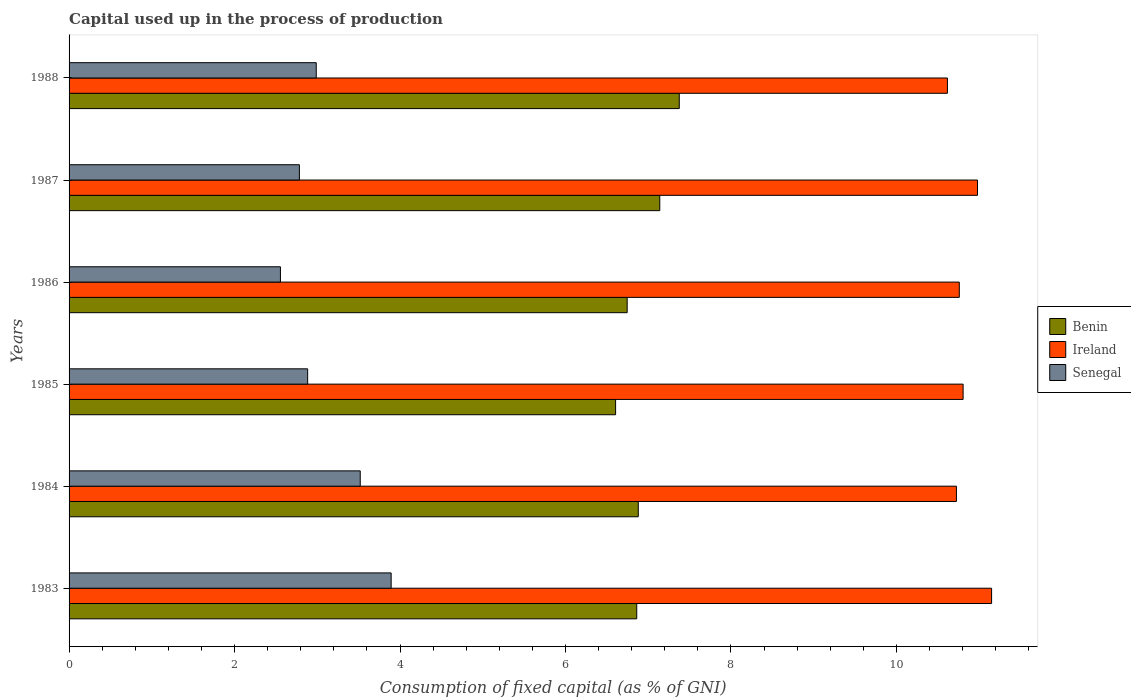Are the number of bars per tick equal to the number of legend labels?
Offer a terse response. Yes. Are the number of bars on each tick of the Y-axis equal?
Provide a succinct answer. Yes. What is the label of the 3rd group of bars from the top?
Ensure brevity in your answer.  1986. What is the capital used up in the process of production in Senegal in 1988?
Provide a succinct answer. 2.99. Across all years, what is the maximum capital used up in the process of production in Senegal?
Keep it short and to the point. 3.89. Across all years, what is the minimum capital used up in the process of production in Ireland?
Your answer should be compact. 10.62. In which year was the capital used up in the process of production in Ireland maximum?
Give a very brief answer. 1983. In which year was the capital used up in the process of production in Ireland minimum?
Your response must be concise. 1988. What is the total capital used up in the process of production in Benin in the graph?
Your answer should be compact. 41.61. What is the difference between the capital used up in the process of production in Senegal in 1985 and that in 1988?
Your answer should be compact. -0.1. What is the difference between the capital used up in the process of production in Ireland in 1988 and the capital used up in the process of production in Benin in 1985?
Your response must be concise. 4.01. What is the average capital used up in the process of production in Ireland per year?
Keep it short and to the point. 10.84. In the year 1987, what is the difference between the capital used up in the process of production in Benin and capital used up in the process of production in Senegal?
Offer a terse response. 4.36. What is the ratio of the capital used up in the process of production in Senegal in 1985 to that in 1986?
Give a very brief answer. 1.13. Is the capital used up in the process of production in Benin in 1985 less than that in 1986?
Keep it short and to the point. Yes. Is the difference between the capital used up in the process of production in Benin in 1984 and 1987 greater than the difference between the capital used up in the process of production in Senegal in 1984 and 1987?
Your response must be concise. No. What is the difference between the highest and the second highest capital used up in the process of production in Ireland?
Keep it short and to the point. 0.17. What is the difference between the highest and the lowest capital used up in the process of production in Benin?
Your answer should be compact. 0.77. In how many years, is the capital used up in the process of production in Ireland greater than the average capital used up in the process of production in Ireland taken over all years?
Provide a short and direct response. 2. What does the 1st bar from the top in 1985 represents?
Keep it short and to the point. Senegal. What does the 3rd bar from the bottom in 1986 represents?
Make the answer very short. Senegal. Is it the case that in every year, the sum of the capital used up in the process of production in Benin and capital used up in the process of production in Senegal is greater than the capital used up in the process of production in Ireland?
Keep it short and to the point. No. How many years are there in the graph?
Your response must be concise. 6. What is the difference between two consecutive major ticks on the X-axis?
Your answer should be very brief. 2. Are the values on the major ticks of X-axis written in scientific E-notation?
Keep it short and to the point. No. What is the title of the graph?
Offer a very short reply. Capital used up in the process of production. What is the label or title of the X-axis?
Provide a succinct answer. Consumption of fixed capital (as % of GNI). What is the Consumption of fixed capital (as % of GNI) in Benin in 1983?
Your answer should be very brief. 6.86. What is the Consumption of fixed capital (as % of GNI) in Ireland in 1983?
Your response must be concise. 11.15. What is the Consumption of fixed capital (as % of GNI) of Senegal in 1983?
Provide a short and direct response. 3.89. What is the Consumption of fixed capital (as % of GNI) of Benin in 1984?
Make the answer very short. 6.88. What is the Consumption of fixed capital (as % of GNI) of Ireland in 1984?
Give a very brief answer. 10.72. What is the Consumption of fixed capital (as % of GNI) of Senegal in 1984?
Offer a terse response. 3.52. What is the Consumption of fixed capital (as % of GNI) in Benin in 1985?
Keep it short and to the point. 6.61. What is the Consumption of fixed capital (as % of GNI) of Ireland in 1985?
Ensure brevity in your answer.  10.81. What is the Consumption of fixed capital (as % of GNI) in Senegal in 1985?
Make the answer very short. 2.88. What is the Consumption of fixed capital (as % of GNI) in Benin in 1986?
Your answer should be very brief. 6.75. What is the Consumption of fixed capital (as % of GNI) of Ireland in 1986?
Keep it short and to the point. 10.76. What is the Consumption of fixed capital (as % of GNI) in Senegal in 1986?
Keep it short and to the point. 2.55. What is the Consumption of fixed capital (as % of GNI) of Benin in 1987?
Make the answer very short. 7.14. What is the Consumption of fixed capital (as % of GNI) in Ireland in 1987?
Offer a very short reply. 10.98. What is the Consumption of fixed capital (as % of GNI) of Senegal in 1987?
Your response must be concise. 2.78. What is the Consumption of fixed capital (as % of GNI) in Benin in 1988?
Make the answer very short. 7.37. What is the Consumption of fixed capital (as % of GNI) in Ireland in 1988?
Provide a succinct answer. 10.62. What is the Consumption of fixed capital (as % of GNI) of Senegal in 1988?
Your response must be concise. 2.99. Across all years, what is the maximum Consumption of fixed capital (as % of GNI) in Benin?
Offer a very short reply. 7.37. Across all years, what is the maximum Consumption of fixed capital (as % of GNI) of Ireland?
Your answer should be compact. 11.15. Across all years, what is the maximum Consumption of fixed capital (as % of GNI) in Senegal?
Your response must be concise. 3.89. Across all years, what is the minimum Consumption of fixed capital (as % of GNI) of Benin?
Offer a very short reply. 6.61. Across all years, what is the minimum Consumption of fixed capital (as % of GNI) in Ireland?
Provide a succinct answer. 10.62. Across all years, what is the minimum Consumption of fixed capital (as % of GNI) of Senegal?
Offer a terse response. 2.55. What is the total Consumption of fixed capital (as % of GNI) of Benin in the graph?
Offer a terse response. 41.61. What is the total Consumption of fixed capital (as % of GNI) in Ireland in the graph?
Offer a very short reply. 65.03. What is the total Consumption of fixed capital (as % of GNI) in Senegal in the graph?
Offer a very short reply. 18.62. What is the difference between the Consumption of fixed capital (as % of GNI) of Benin in 1983 and that in 1984?
Your response must be concise. -0.02. What is the difference between the Consumption of fixed capital (as % of GNI) of Ireland in 1983 and that in 1984?
Your answer should be very brief. 0.43. What is the difference between the Consumption of fixed capital (as % of GNI) in Senegal in 1983 and that in 1984?
Make the answer very short. 0.37. What is the difference between the Consumption of fixed capital (as % of GNI) of Benin in 1983 and that in 1985?
Ensure brevity in your answer.  0.26. What is the difference between the Consumption of fixed capital (as % of GNI) in Ireland in 1983 and that in 1985?
Ensure brevity in your answer.  0.34. What is the difference between the Consumption of fixed capital (as % of GNI) in Senegal in 1983 and that in 1985?
Your response must be concise. 1.01. What is the difference between the Consumption of fixed capital (as % of GNI) in Benin in 1983 and that in 1986?
Keep it short and to the point. 0.12. What is the difference between the Consumption of fixed capital (as % of GNI) of Ireland in 1983 and that in 1986?
Offer a terse response. 0.39. What is the difference between the Consumption of fixed capital (as % of GNI) in Senegal in 1983 and that in 1986?
Your answer should be compact. 1.34. What is the difference between the Consumption of fixed capital (as % of GNI) in Benin in 1983 and that in 1987?
Provide a short and direct response. -0.28. What is the difference between the Consumption of fixed capital (as % of GNI) in Ireland in 1983 and that in 1987?
Keep it short and to the point. 0.17. What is the difference between the Consumption of fixed capital (as % of GNI) of Senegal in 1983 and that in 1987?
Give a very brief answer. 1.11. What is the difference between the Consumption of fixed capital (as % of GNI) of Benin in 1983 and that in 1988?
Keep it short and to the point. -0.51. What is the difference between the Consumption of fixed capital (as % of GNI) of Ireland in 1983 and that in 1988?
Keep it short and to the point. 0.53. What is the difference between the Consumption of fixed capital (as % of GNI) of Senegal in 1983 and that in 1988?
Offer a very short reply. 0.91. What is the difference between the Consumption of fixed capital (as % of GNI) in Benin in 1984 and that in 1985?
Make the answer very short. 0.27. What is the difference between the Consumption of fixed capital (as % of GNI) of Ireland in 1984 and that in 1985?
Keep it short and to the point. -0.08. What is the difference between the Consumption of fixed capital (as % of GNI) in Senegal in 1984 and that in 1985?
Make the answer very short. 0.64. What is the difference between the Consumption of fixed capital (as % of GNI) in Benin in 1984 and that in 1986?
Your response must be concise. 0.13. What is the difference between the Consumption of fixed capital (as % of GNI) of Ireland in 1984 and that in 1986?
Your answer should be compact. -0.03. What is the difference between the Consumption of fixed capital (as % of GNI) of Senegal in 1984 and that in 1986?
Your answer should be compact. 0.96. What is the difference between the Consumption of fixed capital (as % of GNI) of Benin in 1984 and that in 1987?
Offer a very short reply. -0.26. What is the difference between the Consumption of fixed capital (as % of GNI) of Ireland in 1984 and that in 1987?
Keep it short and to the point. -0.25. What is the difference between the Consumption of fixed capital (as % of GNI) of Senegal in 1984 and that in 1987?
Keep it short and to the point. 0.74. What is the difference between the Consumption of fixed capital (as % of GNI) in Benin in 1984 and that in 1988?
Ensure brevity in your answer.  -0.5. What is the difference between the Consumption of fixed capital (as % of GNI) in Ireland in 1984 and that in 1988?
Offer a very short reply. 0.11. What is the difference between the Consumption of fixed capital (as % of GNI) in Senegal in 1984 and that in 1988?
Offer a very short reply. 0.53. What is the difference between the Consumption of fixed capital (as % of GNI) of Benin in 1985 and that in 1986?
Provide a succinct answer. -0.14. What is the difference between the Consumption of fixed capital (as % of GNI) of Ireland in 1985 and that in 1986?
Make the answer very short. 0.05. What is the difference between the Consumption of fixed capital (as % of GNI) of Senegal in 1985 and that in 1986?
Ensure brevity in your answer.  0.33. What is the difference between the Consumption of fixed capital (as % of GNI) of Benin in 1985 and that in 1987?
Your response must be concise. -0.53. What is the difference between the Consumption of fixed capital (as % of GNI) in Ireland in 1985 and that in 1987?
Offer a terse response. -0.17. What is the difference between the Consumption of fixed capital (as % of GNI) in Senegal in 1985 and that in 1987?
Keep it short and to the point. 0.1. What is the difference between the Consumption of fixed capital (as % of GNI) in Benin in 1985 and that in 1988?
Your answer should be very brief. -0.77. What is the difference between the Consumption of fixed capital (as % of GNI) in Ireland in 1985 and that in 1988?
Make the answer very short. 0.19. What is the difference between the Consumption of fixed capital (as % of GNI) in Senegal in 1985 and that in 1988?
Ensure brevity in your answer.  -0.1. What is the difference between the Consumption of fixed capital (as % of GNI) in Benin in 1986 and that in 1987?
Provide a succinct answer. -0.39. What is the difference between the Consumption of fixed capital (as % of GNI) in Ireland in 1986 and that in 1987?
Your response must be concise. -0.22. What is the difference between the Consumption of fixed capital (as % of GNI) in Senegal in 1986 and that in 1987?
Keep it short and to the point. -0.23. What is the difference between the Consumption of fixed capital (as % of GNI) of Benin in 1986 and that in 1988?
Your answer should be compact. -0.63. What is the difference between the Consumption of fixed capital (as % of GNI) in Ireland in 1986 and that in 1988?
Your answer should be compact. 0.14. What is the difference between the Consumption of fixed capital (as % of GNI) of Senegal in 1986 and that in 1988?
Give a very brief answer. -0.43. What is the difference between the Consumption of fixed capital (as % of GNI) of Benin in 1987 and that in 1988?
Your answer should be very brief. -0.24. What is the difference between the Consumption of fixed capital (as % of GNI) in Ireland in 1987 and that in 1988?
Your answer should be very brief. 0.36. What is the difference between the Consumption of fixed capital (as % of GNI) of Senegal in 1987 and that in 1988?
Your answer should be very brief. -0.2. What is the difference between the Consumption of fixed capital (as % of GNI) of Benin in 1983 and the Consumption of fixed capital (as % of GNI) of Ireland in 1984?
Make the answer very short. -3.86. What is the difference between the Consumption of fixed capital (as % of GNI) of Benin in 1983 and the Consumption of fixed capital (as % of GNI) of Senegal in 1984?
Your response must be concise. 3.34. What is the difference between the Consumption of fixed capital (as % of GNI) of Ireland in 1983 and the Consumption of fixed capital (as % of GNI) of Senegal in 1984?
Provide a short and direct response. 7.63. What is the difference between the Consumption of fixed capital (as % of GNI) in Benin in 1983 and the Consumption of fixed capital (as % of GNI) in Ireland in 1985?
Give a very brief answer. -3.94. What is the difference between the Consumption of fixed capital (as % of GNI) of Benin in 1983 and the Consumption of fixed capital (as % of GNI) of Senegal in 1985?
Offer a terse response. 3.98. What is the difference between the Consumption of fixed capital (as % of GNI) in Ireland in 1983 and the Consumption of fixed capital (as % of GNI) in Senegal in 1985?
Provide a short and direct response. 8.27. What is the difference between the Consumption of fixed capital (as % of GNI) of Benin in 1983 and the Consumption of fixed capital (as % of GNI) of Ireland in 1986?
Keep it short and to the point. -3.9. What is the difference between the Consumption of fixed capital (as % of GNI) in Benin in 1983 and the Consumption of fixed capital (as % of GNI) in Senegal in 1986?
Your answer should be very brief. 4.31. What is the difference between the Consumption of fixed capital (as % of GNI) of Ireland in 1983 and the Consumption of fixed capital (as % of GNI) of Senegal in 1986?
Keep it short and to the point. 8.6. What is the difference between the Consumption of fixed capital (as % of GNI) in Benin in 1983 and the Consumption of fixed capital (as % of GNI) in Ireland in 1987?
Give a very brief answer. -4.12. What is the difference between the Consumption of fixed capital (as % of GNI) of Benin in 1983 and the Consumption of fixed capital (as % of GNI) of Senegal in 1987?
Make the answer very short. 4.08. What is the difference between the Consumption of fixed capital (as % of GNI) in Ireland in 1983 and the Consumption of fixed capital (as % of GNI) in Senegal in 1987?
Offer a very short reply. 8.37. What is the difference between the Consumption of fixed capital (as % of GNI) of Benin in 1983 and the Consumption of fixed capital (as % of GNI) of Ireland in 1988?
Keep it short and to the point. -3.76. What is the difference between the Consumption of fixed capital (as % of GNI) of Benin in 1983 and the Consumption of fixed capital (as % of GNI) of Senegal in 1988?
Keep it short and to the point. 3.87. What is the difference between the Consumption of fixed capital (as % of GNI) in Ireland in 1983 and the Consumption of fixed capital (as % of GNI) in Senegal in 1988?
Provide a succinct answer. 8.16. What is the difference between the Consumption of fixed capital (as % of GNI) of Benin in 1984 and the Consumption of fixed capital (as % of GNI) of Ireland in 1985?
Offer a very short reply. -3.93. What is the difference between the Consumption of fixed capital (as % of GNI) of Benin in 1984 and the Consumption of fixed capital (as % of GNI) of Senegal in 1985?
Your response must be concise. 4. What is the difference between the Consumption of fixed capital (as % of GNI) of Ireland in 1984 and the Consumption of fixed capital (as % of GNI) of Senegal in 1985?
Give a very brief answer. 7.84. What is the difference between the Consumption of fixed capital (as % of GNI) of Benin in 1984 and the Consumption of fixed capital (as % of GNI) of Ireland in 1986?
Your response must be concise. -3.88. What is the difference between the Consumption of fixed capital (as % of GNI) in Benin in 1984 and the Consumption of fixed capital (as % of GNI) in Senegal in 1986?
Your response must be concise. 4.33. What is the difference between the Consumption of fixed capital (as % of GNI) of Ireland in 1984 and the Consumption of fixed capital (as % of GNI) of Senegal in 1986?
Your response must be concise. 8.17. What is the difference between the Consumption of fixed capital (as % of GNI) in Benin in 1984 and the Consumption of fixed capital (as % of GNI) in Ireland in 1987?
Your answer should be very brief. -4.1. What is the difference between the Consumption of fixed capital (as % of GNI) of Benin in 1984 and the Consumption of fixed capital (as % of GNI) of Senegal in 1987?
Provide a short and direct response. 4.1. What is the difference between the Consumption of fixed capital (as % of GNI) in Ireland in 1984 and the Consumption of fixed capital (as % of GNI) in Senegal in 1987?
Your answer should be very brief. 7.94. What is the difference between the Consumption of fixed capital (as % of GNI) in Benin in 1984 and the Consumption of fixed capital (as % of GNI) in Ireland in 1988?
Provide a short and direct response. -3.74. What is the difference between the Consumption of fixed capital (as % of GNI) of Benin in 1984 and the Consumption of fixed capital (as % of GNI) of Senegal in 1988?
Keep it short and to the point. 3.89. What is the difference between the Consumption of fixed capital (as % of GNI) in Ireland in 1984 and the Consumption of fixed capital (as % of GNI) in Senegal in 1988?
Offer a very short reply. 7.74. What is the difference between the Consumption of fixed capital (as % of GNI) of Benin in 1985 and the Consumption of fixed capital (as % of GNI) of Ireland in 1986?
Your response must be concise. -4.15. What is the difference between the Consumption of fixed capital (as % of GNI) in Benin in 1985 and the Consumption of fixed capital (as % of GNI) in Senegal in 1986?
Your answer should be very brief. 4.05. What is the difference between the Consumption of fixed capital (as % of GNI) in Ireland in 1985 and the Consumption of fixed capital (as % of GNI) in Senegal in 1986?
Your response must be concise. 8.25. What is the difference between the Consumption of fixed capital (as % of GNI) in Benin in 1985 and the Consumption of fixed capital (as % of GNI) in Ireland in 1987?
Ensure brevity in your answer.  -4.37. What is the difference between the Consumption of fixed capital (as % of GNI) of Benin in 1985 and the Consumption of fixed capital (as % of GNI) of Senegal in 1987?
Offer a terse response. 3.82. What is the difference between the Consumption of fixed capital (as % of GNI) of Ireland in 1985 and the Consumption of fixed capital (as % of GNI) of Senegal in 1987?
Give a very brief answer. 8.02. What is the difference between the Consumption of fixed capital (as % of GNI) of Benin in 1985 and the Consumption of fixed capital (as % of GNI) of Ireland in 1988?
Give a very brief answer. -4.01. What is the difference between the Consumption of fixed capital (as % of GNI) of Benin in 1985 and the Consumption of fixed capital (as % of GNI) of Senegal in 1988?
Make the answer very short. 3.62. What is the difference between the Consumption of fixed capital (as % of GNI) in Ireland in 1985 and the Consumption of fixed capital (as % of GNI) in Senegal in 1988?
Make the answer very short. 7.82. What is the difference between the Consumption of fixed capital (as % of GNI) in Benin in 1986 and the Consumption of fixed capital (as % of GNI) in Ireland in 1987?
Make the answer very short. -4.23. What is the difference between the Consumption of fixed capital (as % of GNI) in Benin in 1986 and the Consumption of fixed capital (as % of GNI) in Senegal in 1987?
Provide a succinct answer. 3.96. What is the difference between the Consumption of fixed capital (as % of GNI) in Ireland in 1986 and the Consumption of fixed capital (as % of GNI) in Senegal in 1987?
Provide a short and direct response. 7.98. What is the difference between the Consumption of fixed capital (as % of GNI) in Benin in 1986 and the Consumption of fixed capital (as % of GNI) in Ireland in 1988?
Provide a succinct answer. -3.87. What is the difference between the Consumption of fixed capital (as % of GNI) in Benin in 1986 and the Consumption of fixed capital (as % of GNI) in Senegal in 1988?
Ensure brevity in your answer.  3.76. What is the difference between the Consumption of fixed capital (as % of GNI) of Ireland in 1986 and the Consumption of fixed capital (as % of GNI) of Senegal in 1988?
Provide a short and direct response. 7.77. What is the difference between the Consumption of fixed capital (as % of GNI) of Benin in 1987 and the Consumption of fixed capital (as % of GNI) of Ireland in 1988?
Your answer should be compact. -3.48. What is the difference between the Consumption of fixed capital (as % of GNI) in Benin in 1987 and the Consumption of fixed capital (as % of GNI) in Senegal in 1988?
Your answer should be compact. 4.15. What is the difference between the Consumption of fixed capital (as % of GNI) of Ireland in 1987 and the Consumption of fixed capital (as % of GNI) of Senegal in 1988?
Make the answer very short. 7.99. What is the average Consumption of fixed capital (as % of GNI) in Benin per year?
Provide a succinct answer. 6.93. What is the average Consumption of fixed capital (as % of GNI) in Ireland per year?
Your answer should be compact. 10.84. What is the average Consumption of fixed capital (as % of GNI) of Senegal per year?
Give a very brief answer. 3.1. In the year 1983, what is the difference between the Consumption of fixed capital (as % of GNI) of Benin and Consumption of fixed capital (as % of GNI) of Ireland?
Your answer should be compact. -4.29. In the year 1983, what is the difference between the Consumption of fixed capital (as % of GNI) of Benin and Consumption of fixed capital (as % of GNI) of Senegal?
Ensure brevity in your answer.  2.97. In the year 1983, what is the difference between the Consumption of fixed capital (as % of GNI) of Ireland and Consumption of fixed capital (as % of GNI) of Senegal?
Your answer should be very brief. 7.26. In the year 1984, what is the difference between the Consumption of fixed capital (as % of GNI) in Benin and Consumption of fixed capital (as % of GNI) in Ireland?
Provide a succinct answer. -3.85. In the year 1984, what is the difference between the Consumption of fixed capital (as % of GNI) in Benin and Consumption of fixed capital (as % of GNI) in Senegal?
Provide a short and direct response. 3.36. In the year 1984, what is the difference between the Consumption of fixed capital (as % of GNI) of Ireland and Consumption of fixed capital (as % of GNI) of Senegal?
Offer a terse response. 7.21. In the year 1985, what is the difference between the Consumption of fixed capital (as % of GNI) of Benin and Consumption of fixed capital (as % of GNI) of Senegal?
Your answer should be compact. 3.72. In the year 1985, what is the difference between the Consumption of fixed capital (as % of GNI) in Ireland and Consumption of fixed capital (as % of GNI) in Senegal?
Provide a short and direct response. 7.92. In the year 1986, what is the difference between the Consumption of fixed capital (as % of GNI) in Benin and Consumption of fixed capital (as % of GNI) in Ireland?
Provide a succinct answer. -4.01. In the year 1986, what is the difference between the Consumption of fixed capital (as % of GNI) in Benin and Consumption of fixed capital (as % of GNI) in Senegal?
Ensure brevity in your answer.  4.19. In the year 1986, what is the difference between the Consumption of fixed capital (as % of GNI) in Ireland and Consumption of fixed capital (as % of GNI) in Senegal?
Ensure brevity in your answer.  8.2. In the year 1987, what is the difference between the Consumption of fixed capital (as % of GNI) in Benin and Consumption of fixed capital (as % of GNI) in Ireland?
Your answer should be very brief. -3.84. In the year 1987, what is the difference between the Consumption of fixed capital (as % of GNI) of Benin and Consumption of fixed capital (as % of GNI) of Senegal?
Provide a succinct answer. 4.36. In the year 1987, what is the difference between the Consumption of fixed capital (as % of GNI) in Ireland and Consumption of fixed capital (as % of GNI) in Senegal?
Your response must be concise. 8.2. In the year 1988, what is the difference between the Consumption of fixed capital (as % of GNI) in Benin and Consumption of fixed capital (as % of GNI) in Ireland?
Your answer should be compact. -3.24. In the year 1988, what is the difference between the Consumption of fixed capital (as % of GNI) of Benin and Consumption of fixed capital (as % of GNI) of Senegal?
Offer a very short reply. 4.39. In the year 1988, what is the difference between the Consumption of fixed capital (as % of GNI) of Ireland and Consumption of fixed capital (as % of GNI) of Senegal?
Make the answer very short. 7.63. What is the ratio of the Consumption of fixed capital (as % of GNI) of Ireland in 1983 to that in 1984?
Provide a short and direct response. 1.04. What is the ratio of the Consumption of fixed capital (as % of GNI) of Senegal in 1983 to that in 1984?
Keep it short and to the point. 1.11. What is the ratio of the Consumption of fixed capital (as % of GNI) of Benin in 1983 to that in 1985?
Keep it short and to the point. 1.04. What is the ratio of the Consumption of fixed capital (as % of GNI) in Ireland in 1983 to that in 1985?
Your answer should be compact. 1.03. What is the ratio of the Consumption of fixed capital (as % of GNI) in Senegal in 1983 to that in 1985?
Keep it short and to the point. 1.35. What is the ratio of the Consumption of fixed capital (as % of GNI) in Benin in 1983 to that in 1986?
Offer a terse response. 1.02. What is the ratio of the Consumption of fixed capital (as % of GNI) in Ireland in 1983 to that in 1986?
Provide a succinct answer. 1.04. What is the ratio of the Consumption of fixed capital (as % of GNI) of Senegal in 1983 to that in 1986?
Your answer should be very brief. 1.52. What is the ratio of the Consumption of fixed capital (as % of GNI) of Benin in 1983 to that in 1987?
Make the answer very short. 0.96. What is the ratio of the Consumption of fixed capital (as % of GNI) in Ireland in 1983 to that in 1987?
Your response must be concise. 1.02. What is the ratio of the Consumption of fixed capital (as % of GNI) of Senegal in 1983 to that in 1987?
Your answer should be very brief. 1.4. What is the ratio of the Consumption of fixed capital (as % of GNI) of Benin in 1983 to that in 1988?
Offer a very short reply. 0.93. What is the ratio of the Consumption of fixed capital (as % of GNI) in Ireland in 1983 to that in 1988?
Provide a short and direct response. 1.05. What is the ratio of the Consumption of fixed capital (as % of GNI) in Senegal in 1983 to that in 1988?
Ensure brevity in your answer.  1.3. What is the ratio of the Consumption of fixed capital (as % of GNI) in Benin in 1984 to that in 1985?
Offer a very short reply. 1.04. What is the ratio of the Consumption of fixed capital (as % of GNI) in Senegal in 1984 to that in 1985?
Provide a succinct answer. 1.22. What is the ratio of the Consumption of fixed capital (as % of GNI) in Benin in 1984 to that in 1986?
Ensure brevity in your answer.  1.02. What is the ratio of the Consumption of fixed capital (as % of GNI) of Senegal in 1984 to that in 1986?
Your answer should be compact. 1.38. What is the ratio of the Consumption of fixed capital (as % of GNI) of Benin in 1984 to that in 1987?
Offer a very short reply. 0.96. What is the ratio of the Consumption of fixed capital (as % of GNI) of Ireland in 1984 to that in 1987?
Provide a succinct answer. 0.98. What is the ratio of the Consumption of fixed capital (as % of GNI) in Senegal in 1984 to that in 1987?
Ensure brevity in your answer.  1.26. What is the ratio of the Consumption of fixed capital (as % of GNI) in Benin in 1984 to that in 1988?
Keep it short and to the point. 0.93. What is the ratio of the Consumption of fixed capital (as % of GNI) of Ireland in 1984 to that in 1988?
Your answer should be very brief. 1.01. What is the ratio of the Consumption of fixed capital (as % of GNI) of Senegal in 1984 to that in 1988?
Ensure brevity in your answer.  1.18. What is the ratio of the Consumption of fixed capital (as % of GNI) in Benin in 1985 to that in 1986?
Ensure brevity in your answer.  0.98. What is the ratio of the Consumption of fixed capital (as % of GNI) of Ireland in 1985 to that in 1986?
Give a very brief answer. 1. What is the ratio of the Consumption of fixed capital (as % of GNI) in Senegal in 1985 to that in 1986?
Keep it short and to the point. 1.13. What is the ratio of the Consumption of fixed capital (as % of GNI) in Benin in 1985 to that in 1987?
Your answer should be very brief. 0.93. What is the ratio of the Consumption of fixed capital (as % of GNI) in Ireland in 1985 to that in 1987?
Offer a terse response. 0.98. What is the ratio of the Consumption of fixed capital (as % of GNI) in Senegal in 1985 to that in 1987?
Your answer should be compact. 1.04. What is the ratio of the Consumption of fixed capital (as % of GNI) in Benin in 1985 to that in 1988?
Provide a short and direct response. 0.9. What is the ratio of the Consumption of fixed capital (as % of GNI) in Ireland in 1985 to that in 1988?
Your answer should be very brief. 1.02. What is the ratio of the Consumption of fixed capital (as % of GNI) in Senegal in 1985 to that in 1988?
Offer a terse response. 0.97. What is the ratio of the Consumption of fixed capital (as % of GNI) in Benin in 1986 to that in 1987?
Offer a terse response. 0.94. What is the ratio of the Consumption of fixed capital (as % of GNI) in Senegal in 1986 to that in 1987?
Provide a succinct answer. 0.92. What is the ratio of the Consumption of fixed capital (as % of GNI) in Benin in 1986 to that in 1988?
Keep it short and to the point. 0.91. What is the ratio of the Consumption of fixed capital (as % of GNI) in Ireland in 1986 to that in 1988?
Your answer should be compact. 1.01. What is the ratio of the Consumption of fixed capital (as % of GNI) in Senegal in 1986 to that in 1988?
Provide a short and direct response. 0.86. What is the ratio of the Consumption of fixed capital (as % of GNI) in Benin in 1987 to that in 1988?
Your response must be concise. 0.97. What is the ratio of the Consumption of fixed capital (as % of GNI) in Ireland in 1987 to that in 1988?
Give a very brief answer. 1.03. What is the ratio of the Consumption of fixed capital (as % of GNI) of Senegal in 1987 to that in 1988?
Your response must be concise. 0.93. What is the difference between the highest and the second highest Consumption of fixed capital (as % of GNI) in Benin?
Your answer should be very brief. 0.24. What is the difference between the highest and the second highest Consumption of fixed capital (as % of GNI) in Ireland?
Your answer should be very brief. 0.17. What is the difference between the highest and the second highest Consumption of fixed capital (as % of GNI) in Senegal?
Ensure brevity in your answer.  0.37. What is the difference between the highest and the lowest Consumption of fixed capital (as % of GNI) of Benin?
Ensure brevity in your answer.  0.77. What is the difference between the highest and the lowest Consumption of fixed capital (as % of GNI) of Ireland?
Your answer should be compact. 0.53. What is the difference between the highest and the lowest Consumption of fixed capital (as % of GNI) in Senegal?
Ensure brevity in your answer.  1.34. 